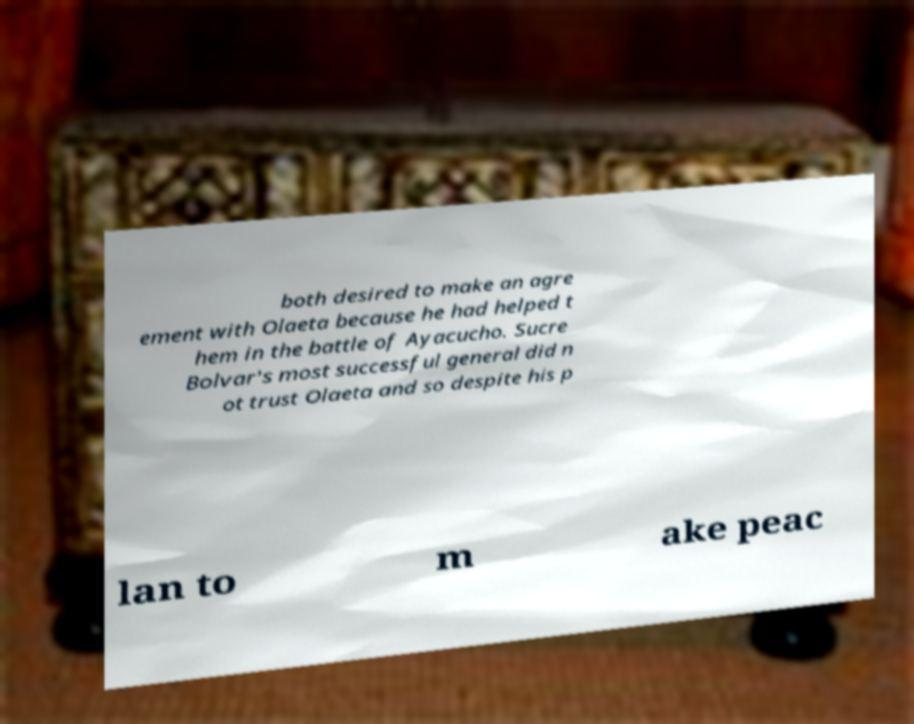Can you read and provide the text displayed in the image?This photo seems to have some interesting text. Can you extract and type it out for me? both desired to make an agre ement with Olaeta because he had helped t hem in the battle of Ayacucho. Sucre Bolvar's most successful general did n ot trust Olaeta and so despite his p lan to m ake peac 